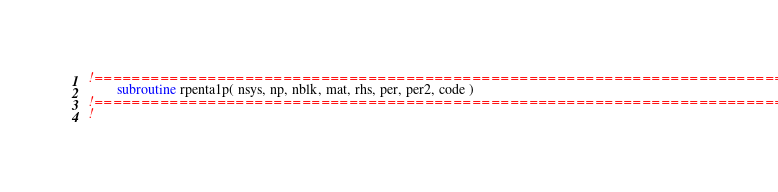Convert code to text. <code><loc_0><loc_0><loc_500><loc_500><_FORTRAN_>!=============================================================================!
        subroutine rpenta1p( nsys, np, nblk, mat, rhs, per, per2, code )
!=============================================================================!
!  </code> 